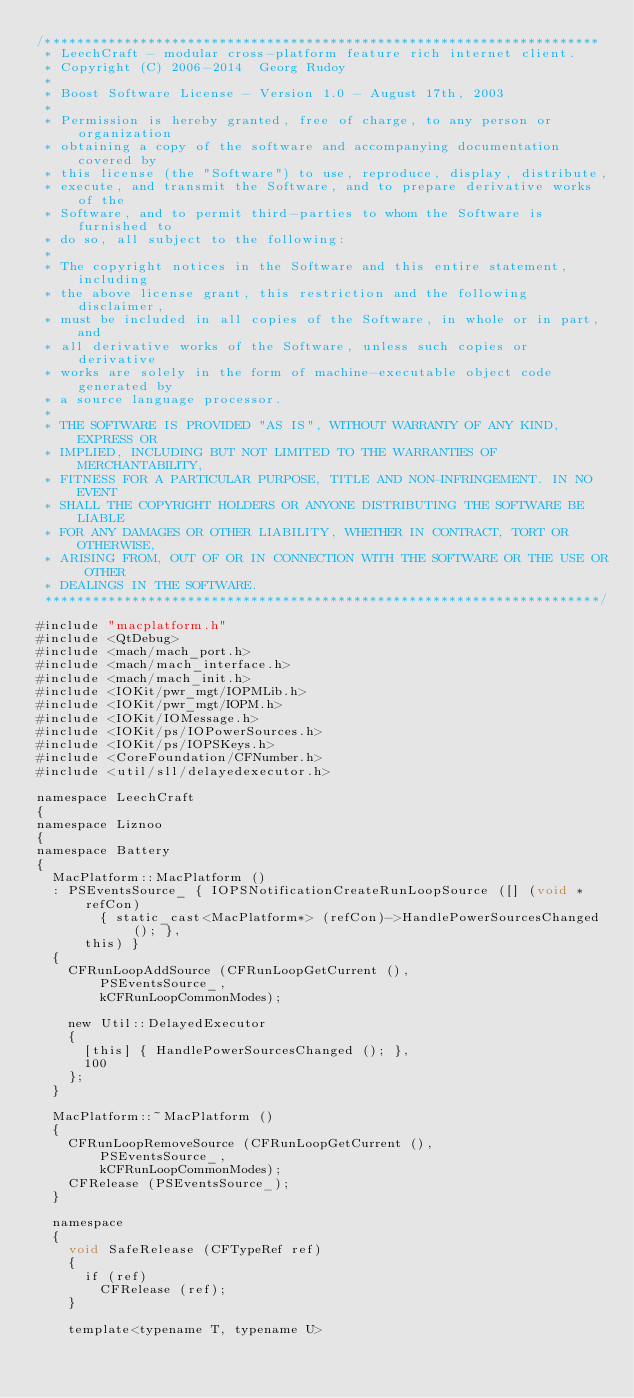Convert code to text. <code><loc_0><loc_0><loc_500><loc_500><_ObjectiveC_>/**********************************************************************
 * LeechCraft - modular cross-platform feature rich internet client.
 * Copyright (C) 2006-2014  Georg Rudoy
 *
 * Boost Software License - Version 1.0 - August 17th, 2003
 *
 * Permission is hereby granted, free of charge, to any person or organization
 * obtaining a copy of the software and accompanying documentation covered by
 * this license (the "Software") to use, reproduce, display, distribute,
 * execute, and transmit the Software, and to prepare derivative works of the
 * Software, and to permit third-parties to whom the Software is furnished to
 * do so, all subject to the following:
 *
 * The copyright notices in the Software and this entire statement, including
 * the above license grant, this restriction and the following disclaimer,
 * must be included in all copies of the Software, in whole or in part, and
 * all derivative works of the Software, unless such copies or derivative
 * works are solely in the form of machine-executable object code generated by
 * a source language processor.
 *
 * THE SOFTWARE IS PROVIDED "AS IS", WITHOUT WARRANTY OF ANY KIND, EXPRESS OR
 * IMPLIED, INCLUDING BUT NOT LIMITED TO THE WARRANTIES OF MERCHANTABILITY,
 * FITNESS FOR A PARTICULAR PURPOSE, TITLE AND NON-INFRINGEMENT. IN NO EVENT
 * SHALL THE COPYRIGHT HOLDERS OR ANYONE DISTRIBUTING THE SOFTWARE BE LIABLE
 * FOR ANY DAMAGES OR OTHER LIABILITY, WHETHER IN CONTRACT, TORT OR OTHERWISE,
 * ARISING FROM, OUT OF OR IN CONNECTION WITH THE SOFTWARE OR THE USE OR OTHER
 * DEALINGS IN THE SOFTWARE.
 **********************************************************************/

#include "macplatform.h"
#include <QtDebug>
#include <mach/mach_port.h>
#include <mach/mach_interface.h>
#include <mach/mach_init.h>
#include <IOKit/pwr_mgt/IOPMLib.h>
#include <IOKit/pwr_mgt/IOPM.h>
#include <IOKit/IOMessage.h>
#include <IOKit/ps/IOPowerSources.h>
#include <IOKit/ps/IOPSKeys.h>
#include <CoreFoundation/CFNumber.h>
#include <util/sll/delayedexecutor.h>

namespace LeechCraft
{
namespace Liznoo
{
namespace Battery
{
	MacPlatform::MacPlatform ()
	: PSEventsSource_ { IOPSNotificationCreateRunLoopSource ([] (void *refCon)
				{ static_cast<MacPlatform*> (refCon)->HandlePowerSourcesChanged (); },
			this) }
	{
		CFRunLoopAddSource (CFRunLoopGetCurrent (),
				PSEventsSource_,
				kCFRunLoopCommonModes);

		new Util::DelayedExecutor
		{
			[this] { HandlePowerSourcesChanged (); },
			100
		};
	}

	MacPlatform::~MacPlatform ()
	{
		CFRunLoopRemoveSource (CFRunLoopGetCurrent (),
				PSEventsSource_,
				kCFRunLoopCommonModes);
		CFRelease (PSEventsSource_);
	}

	namespace
	{
		void SafeRelease (CFTypeRef ref)
		{
			if (ref)
				CFRelease (ref);
		}

		template<typename T, typename U></code> 